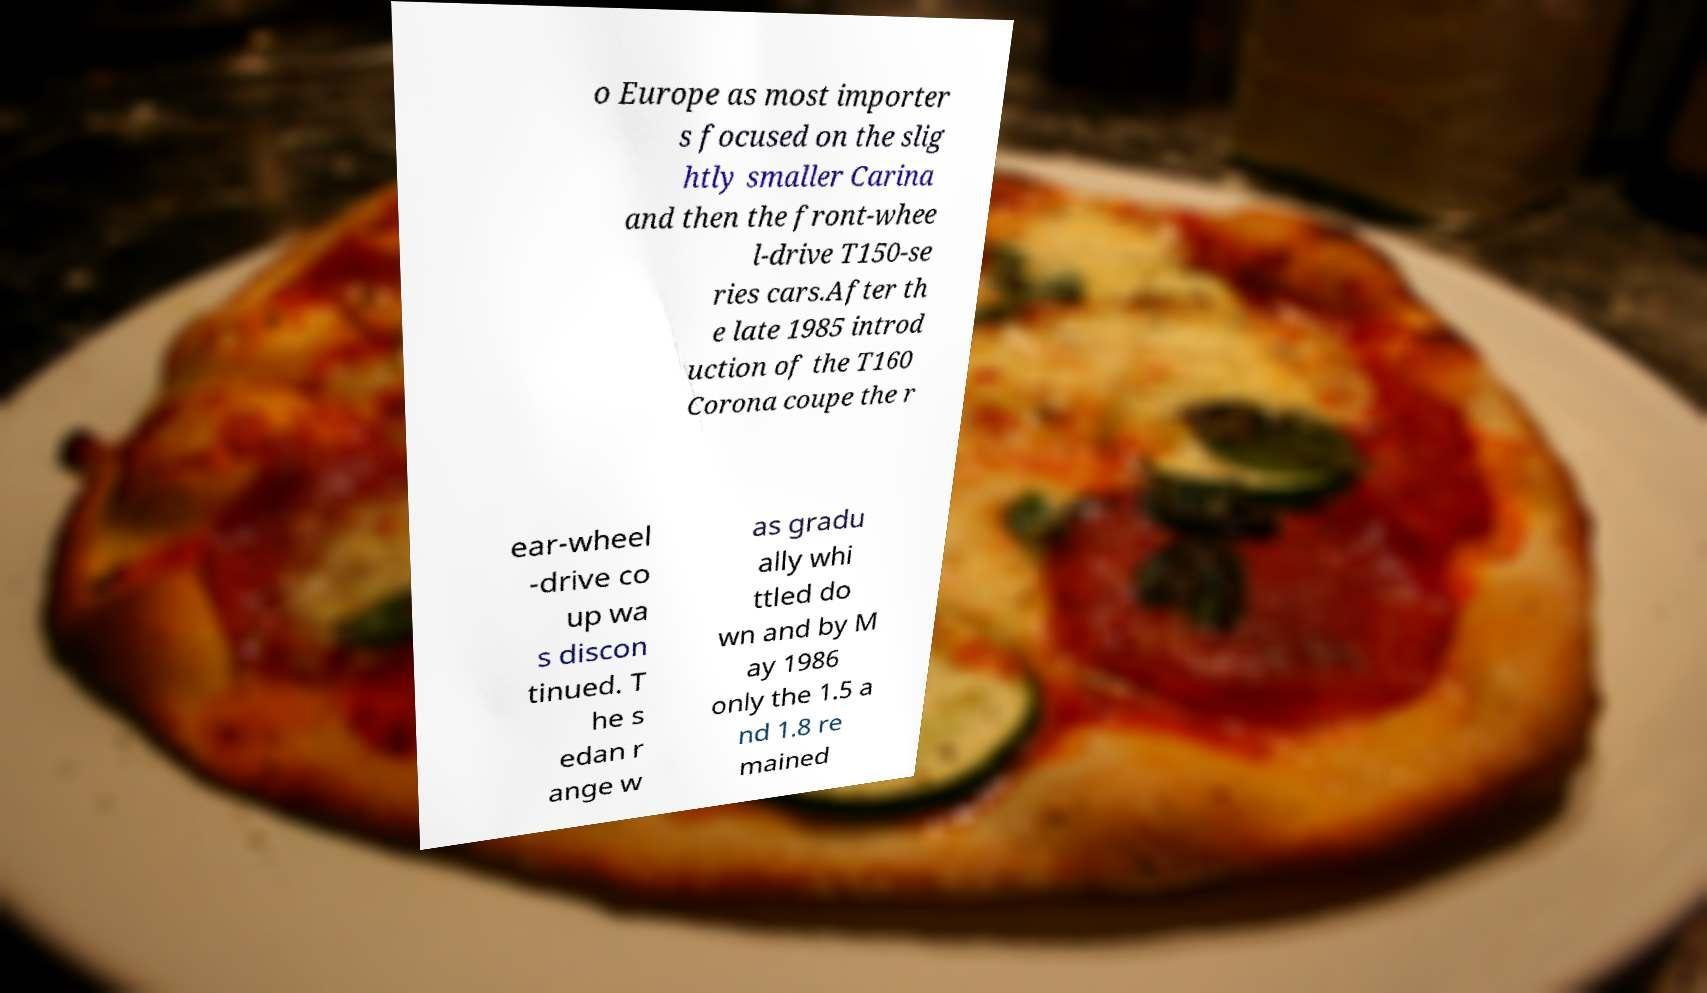Please identify and transcribe the text found in this image. o Europe as most importer s focused on the slig htly smaller Carina and then the front-whee l-drive T150-se ries cars.After th e late 1985 introd uction of the T160 Corona coupe the r ear-wheel -drive co up wa s discon tinued. T he s edan r ange w as gradu ally whi ttled do wn and by M ay 1986 only the 1.5 a nd 1.8 re mained 